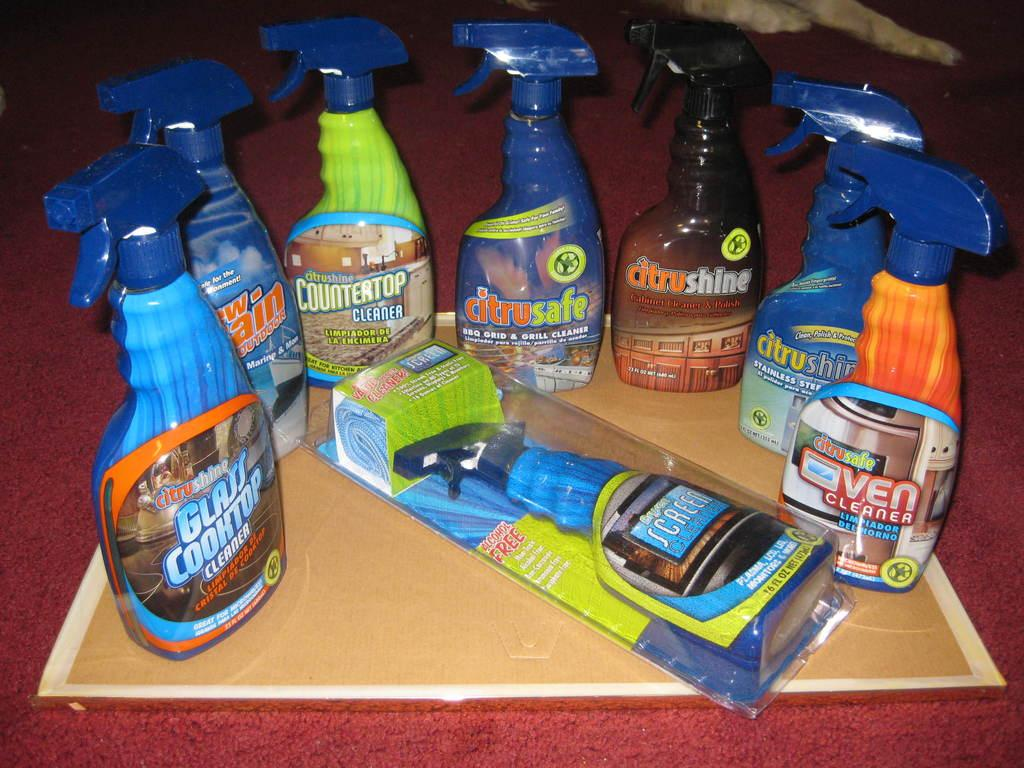<image>
Relay a brief, clear account of the picture shown. Glass Cook top spray on the left next to some other cleaning sprays. 